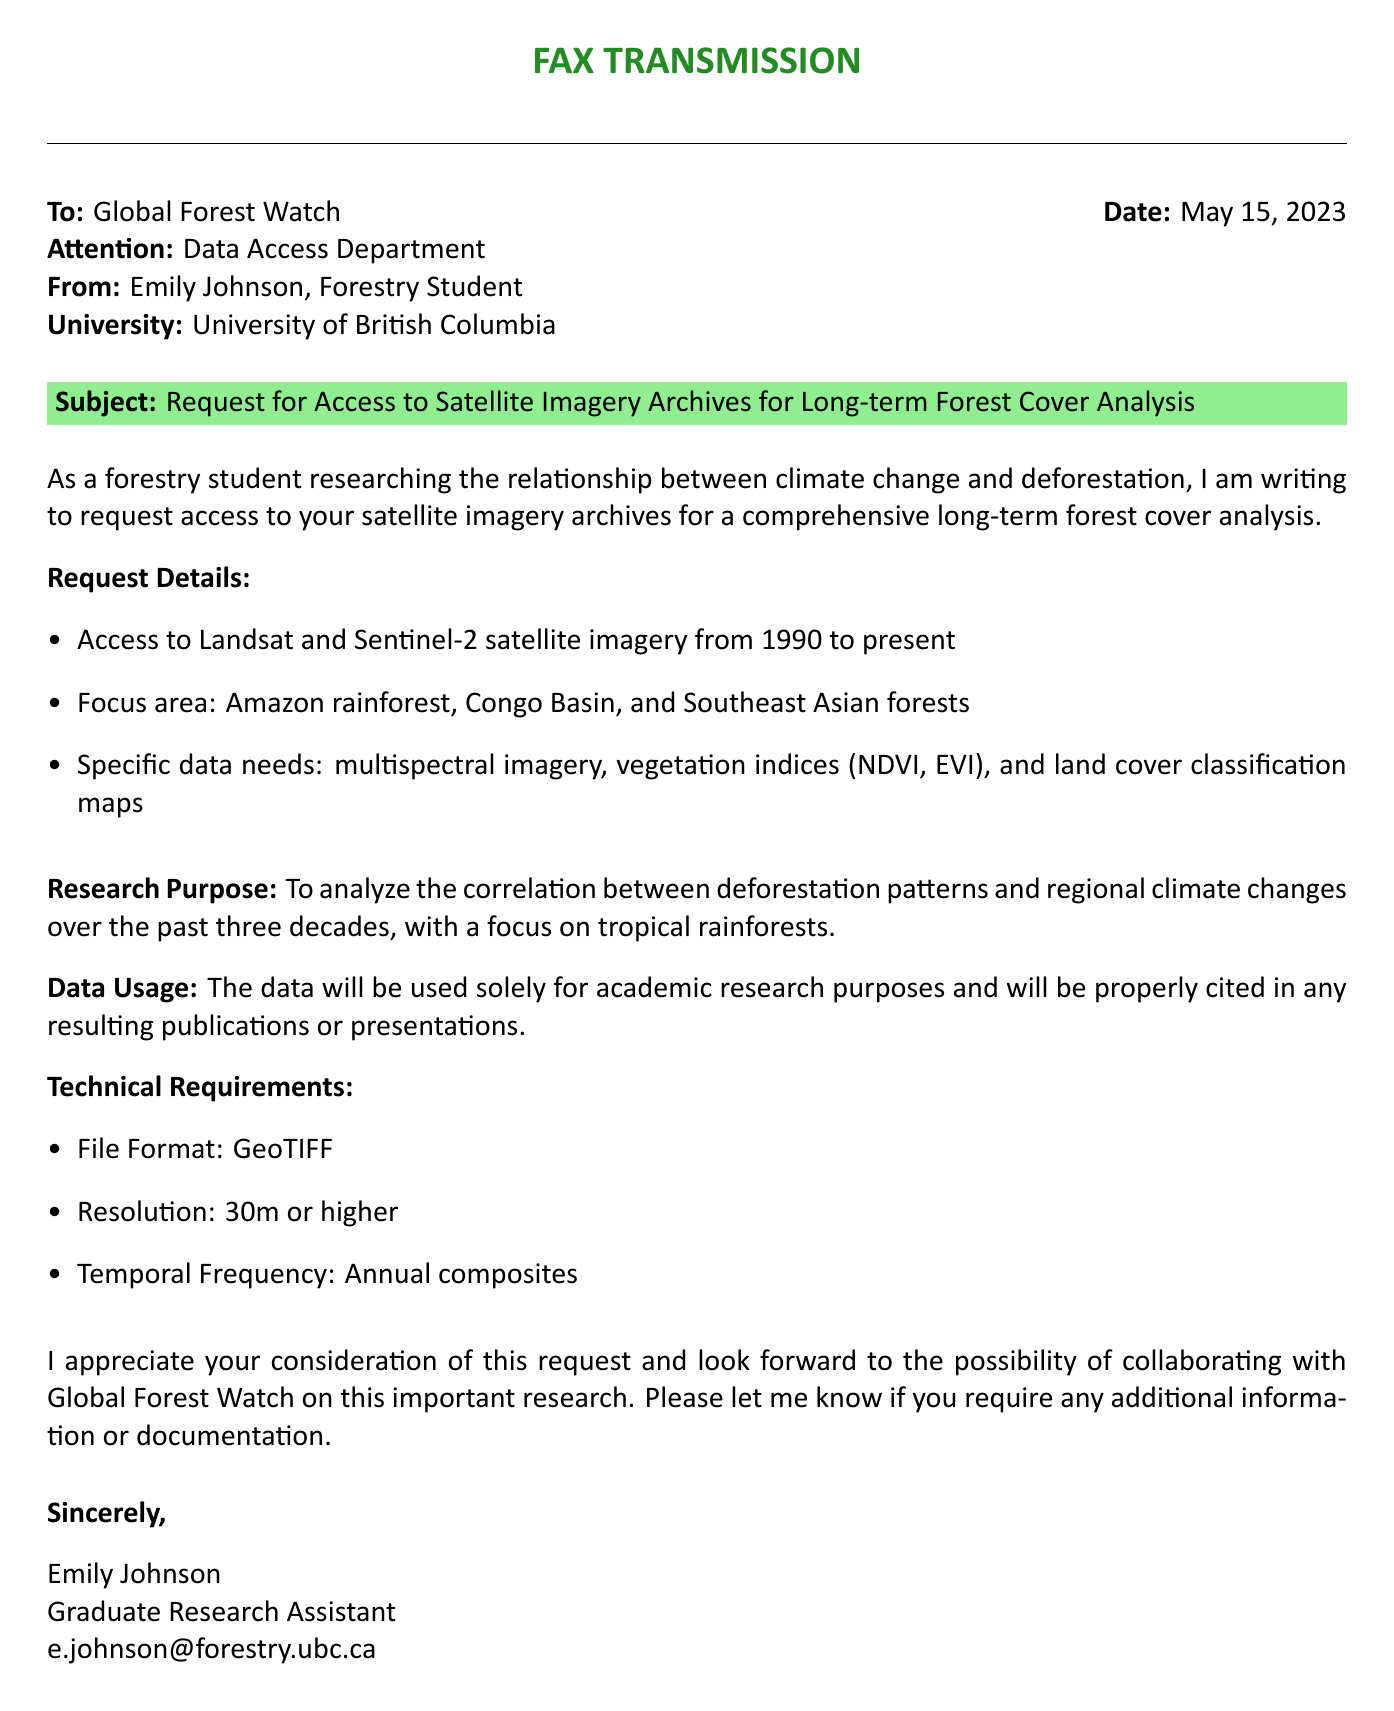What is the date of the fax? The date of the fax is stated at the top of the document under the 'Date' heading.
Answer: May 15, 2023 Who is the sender of the fax? The sender's name is provided in the 'From' section of the fax.
Answer: Emily Johnson What is the subject of the fax? The subject is highlighted in the document and summarizes the request.
Answer: Request for Access to Satellite Imagery Archives for Long-term Forest Cover Analysis What is the focus area of the requested data? The focus area is detailed in the 'Request Details' section and identifies specific regions of interest.
Answer: Amazon rainforest, Congo Basin, and Southeast Asian forests What is the required file format for the data? The file format required is indicated under 'Technical Requirements' in the document.
Answer: GeoTIFF What is the purpose of the research? The research purpose is mentioned in a specific section of the document and clarifies the intent of the study.
Answer: To analyze the correlation between deforestation patterns and regional climate changes over the past three decades What is the resolution requested for the imagery? The resolution is specified in the 'Technical Requirements' section of the fax.
Answer: 30m or higher What type of imagery is requested? The type of imagery requested is mentioned in the 'Request Details' under specific data needs.
Answer: multispectral imagery Who is the recipient of the fax? The recipient is mentioned at the beginning of the fax, specifying the organization.
Answer: Global Forest Watch 